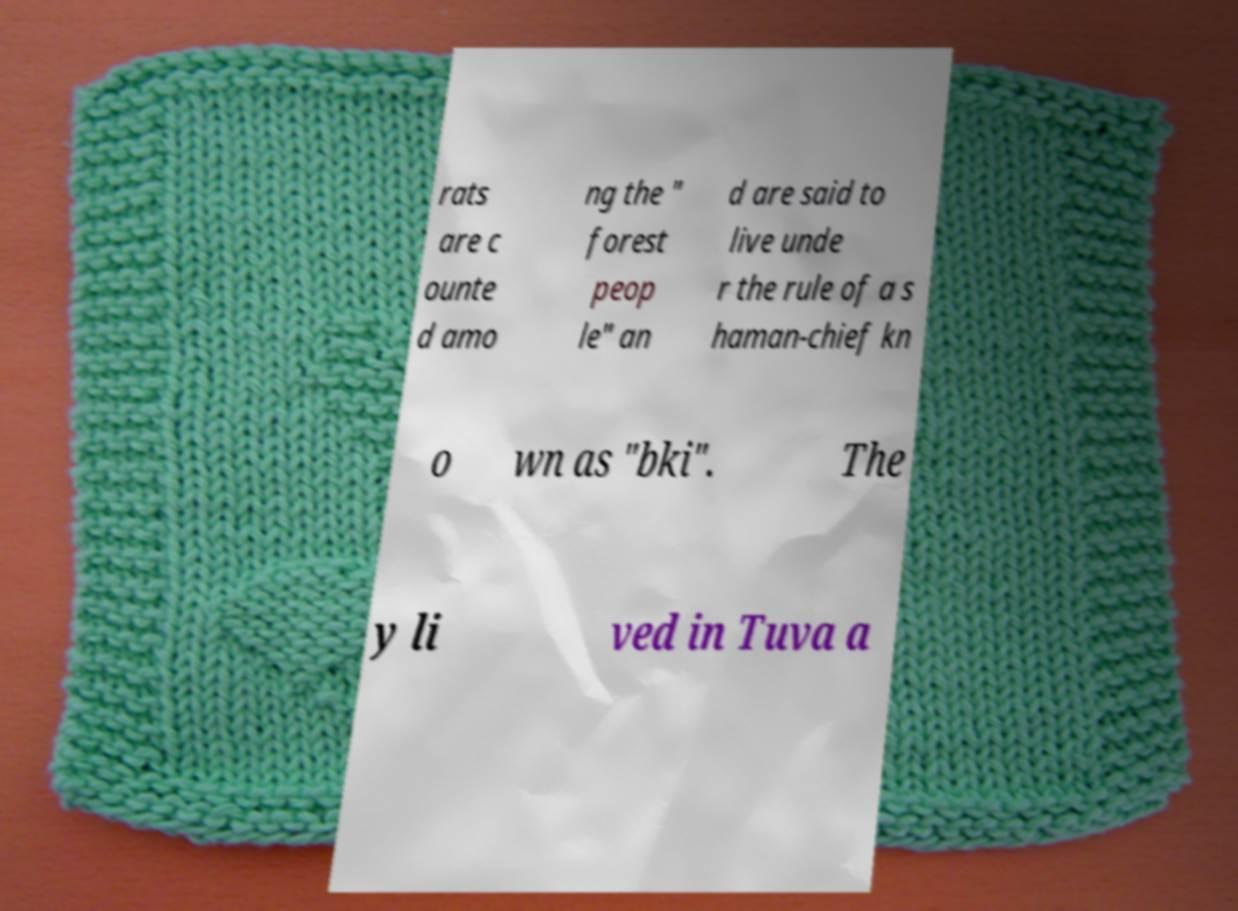Please identify and transcribe the text found in this image. rats are c ounte d amo ng the " forest peop le" an d are said to live unde r the rule of a s haman-chief kn o wn as "bki". The y li ved in Tuva a 